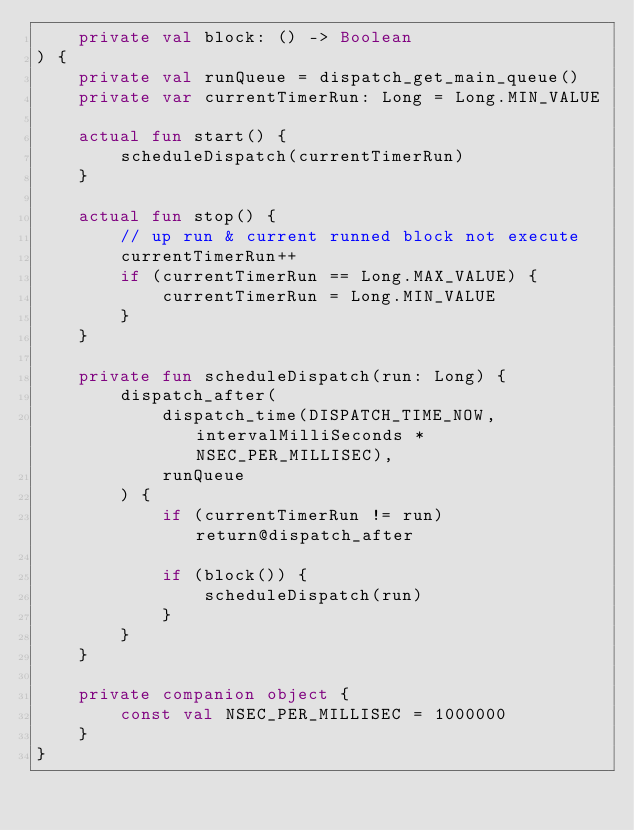Convert code to text. <code><loc_0><loc_0><loc_500><loc_500><_Kotlin_>    private val block: () -> Boolean
) {
    private val runQueue = dispatch_get_main_queue()
    private var currentTimerRun: Long = Long.MIN_VALUE

    actual fun start() {
        scheduleDispatch(currentTimerRun)
    }

    actual fun stop() {
        // up run & current runned block not execute
        currentTimerRun++
        if (currentTimerRun == Long.MAX_VALUE) {
            currentTimerRun = Long.MIN_VALUE
        }
    }

    private fun scheduleDispatch(run: Long) {
        dispatch_after(
            dispatch_time(DISPATCH_TIME_NOW, intervalMilliSeconds * NSEC_PER_MILLISEC),
            runQueue
        ) {
            if (currentTimerRun != run) return@dispatch_after

            if (block()) {
                scheduleDispatch(run)
            }
        }
    }

    private companion object {
        const val NSEC_PER_MILLISEC = 1000000
    }
}
</code> 